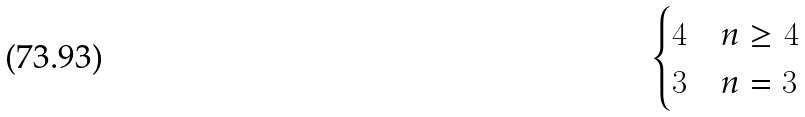Convert formula to latex. <formula><loc_0><loc_0><loc_500><loc_500>\begin{cases} 4 & n \geq 4 \\ 3 & n = 3 \end{cases}</formula> 